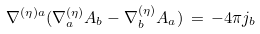<formula> <loc_0><loc_0><loc_500><loc_500>\nabla ^ { ( \eta ) a } ( \nabla ^ { ( \eta ) } _ { a } A _ { b } - \nabla ^ { ( \eta ) } _ { b } A _ { a } ) \, = \, - 4 \pi j _ { b }</formula> 